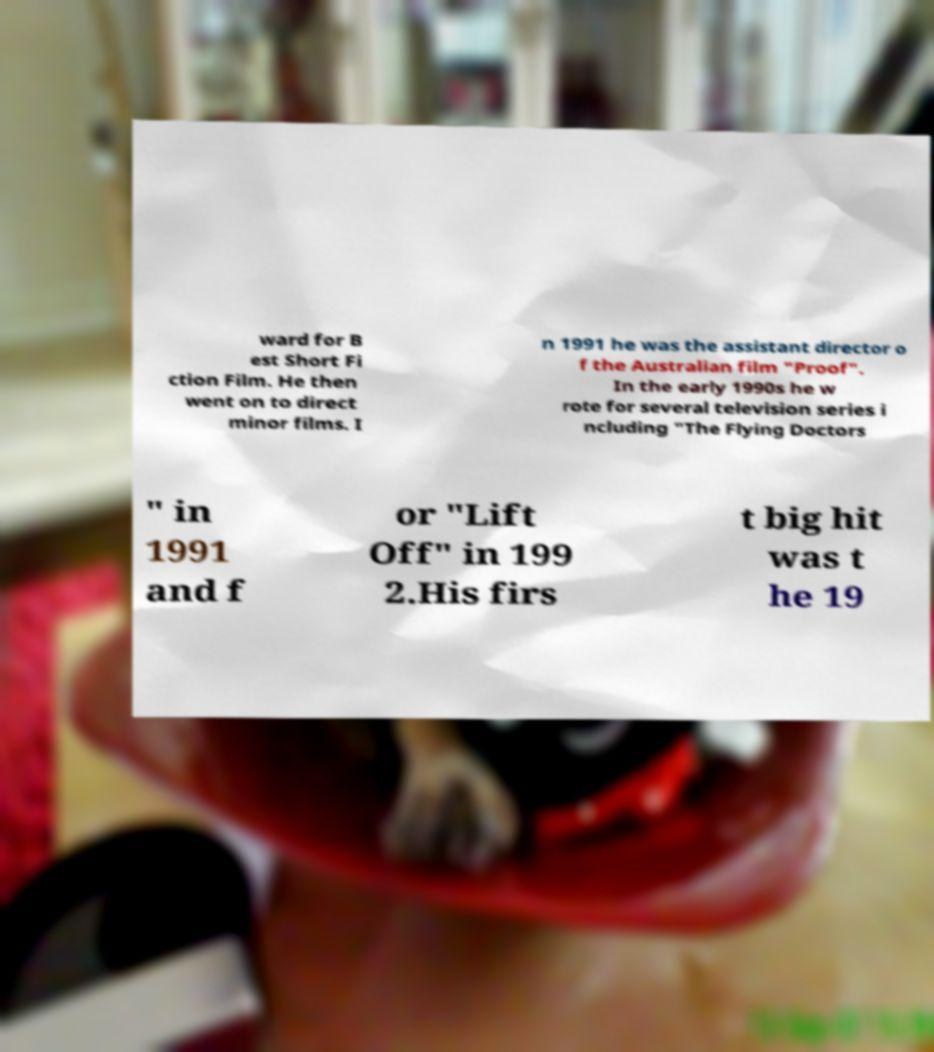Could you assist in decoding the text presented in this image and type it out clearly? ward for B est Short Fi ction Film. He then went on to direct minor films. I n 1991 he was the assistant director o f the Australian film "Proof". In the early 1990s he w rote for several television series i ncluding "The Flying Doctors " in 1991 and f or "Lift Off" in 199 2.His firs t big hit was t he 19 